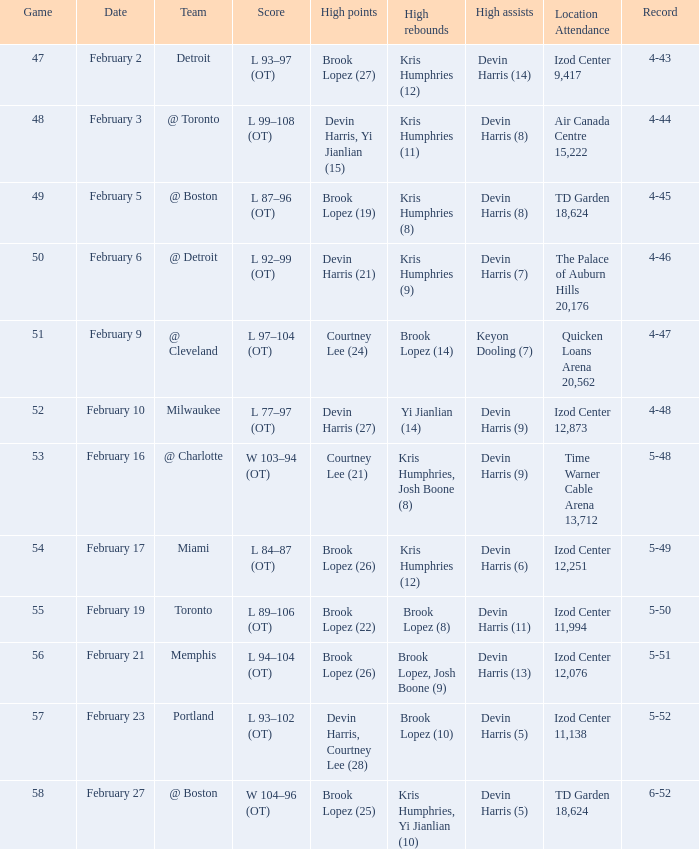What was the score of the game in which Brook Lopez (8) did the high rebounds? L 89–106 (OT). 